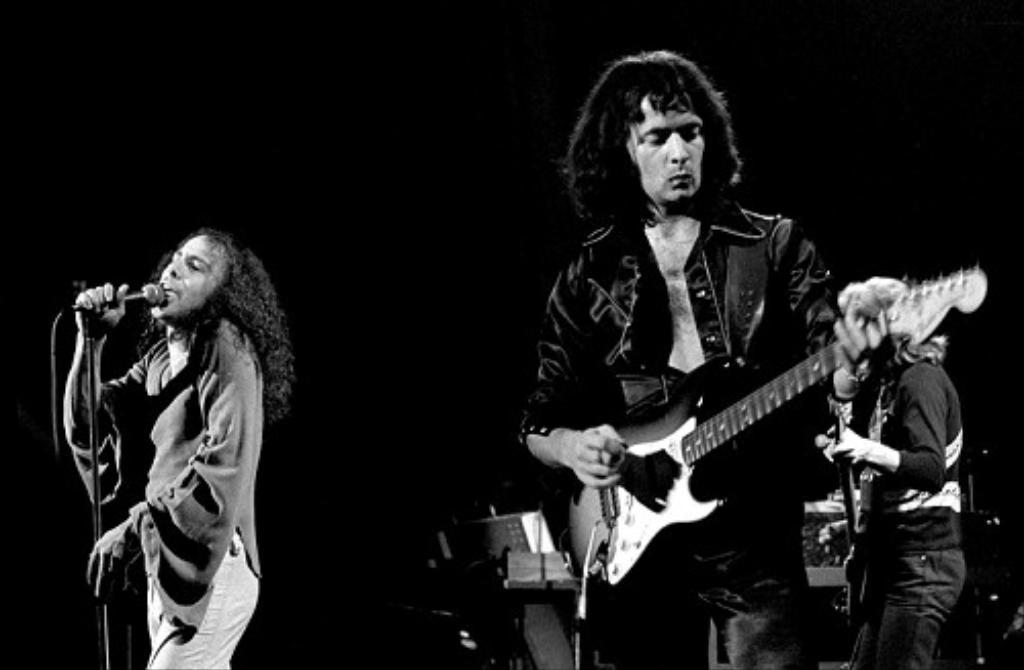Describe this image in one or two sentences. Here we can see that a person is standing and playing guitar, and at behind a person is standing and singing and holding a microphone in his hands, and at back a person is standing. 